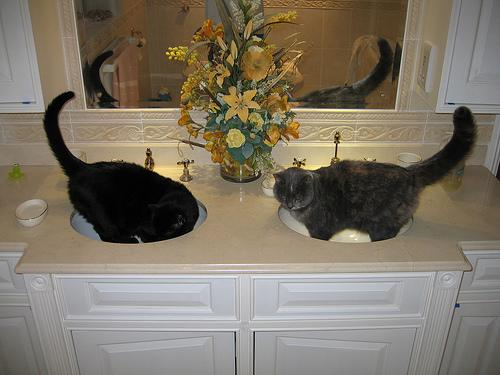Express the overall emotion or sentiment of the image. The image displays a playful and cute atmosphere due to the presence of two cats in the sinks. Identify the primary objects in the image and mention their positions. Two cats, a gray one in the left sink and a black one in the right sink, a vase with flowers on the counter, a mirror above the sinks, and cupboards under the sinks. Analyze how the objects and subjects in the image interact with each other. The two cats in the sinks create a focal point in the image, while the other objects like the mirror, flowers, towels, and cabinets complement the scene by creating a typical bathroom environment. How many cats are present in the image and where are they located? There are two cats, one gray cat in the left sink and one black cat in the right sink. Quantify the number of flowers and their location in the image. There is one yellow bouquet on the counter containing multiple flowers, with one prominent lily. In the image, what type of room is depicted, and what is unusual about this room? The image portrays a bathroom, and the unusual aspect is the presence of two cats sitting in two sinks. Briefly describe the scene in the image. The image depicts a bathroom scene with two cats sitting in separate sinks, a mirror reflecting the tails of the cats, a vase of flowers on the counter, and cupboards below the sinks. Count the total number of visible sinks and describe their material. There are two visible sinks, which appear to be made of white ceramic material. Describe the reflection in the mirror and any object associated with it. The reflection in the mirror shows the tails of the two cats and a pink towel hanging on the wall. Point out any prominent colors present in the image. Prominent colors in the image are white (sinks, cabinets, and wall), black (cat), gray (cat), and yellow (bouquet). 